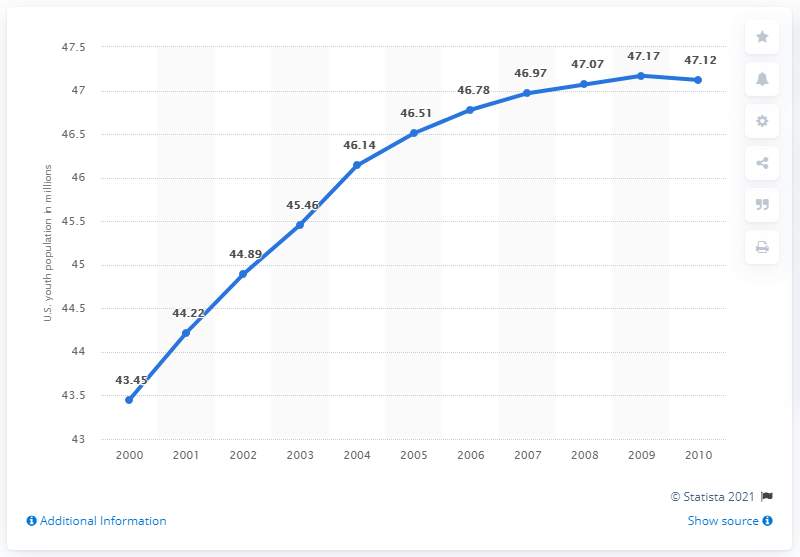What might have influenced the growth of the young population during this period? Several factors could have influenced the growth of the young population during this period, including higher birth rates in previous years, immigration, and potentially lower mortality rates among this age group. 